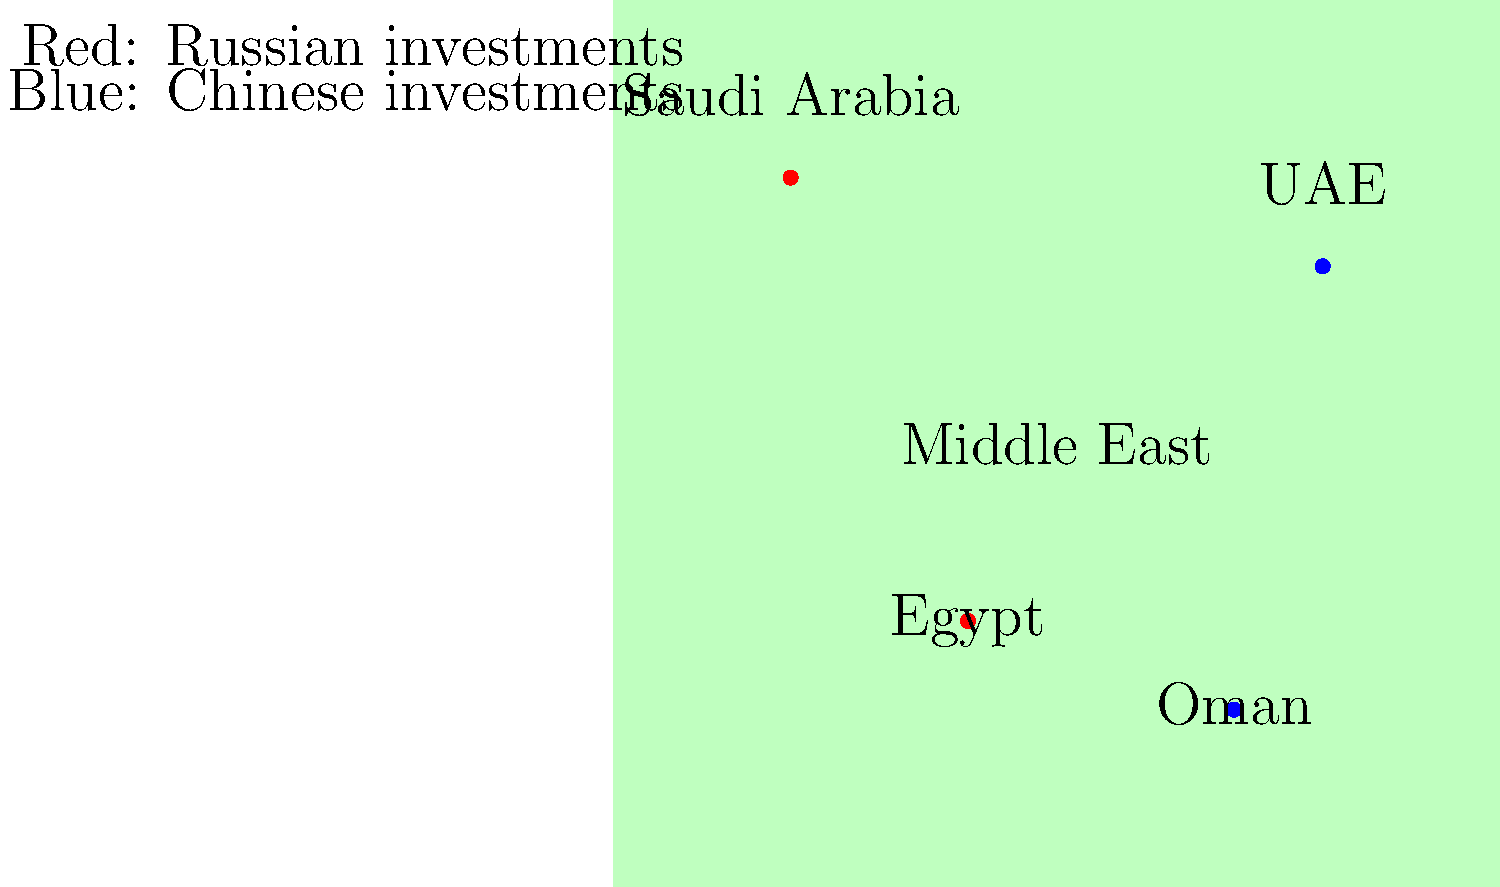Based on the color-coded map of Russian and Chinese economic investments in the Middle East, which country appears to have significant Chinese investment but is geographically closer to countries with Russian investment? To answer this question, we need to analyze the map step-by-step:

1. Identify the color coding:
   - Red dots represent Russian investments
   - Blue dots represent Chinese investments

2. Locate the countries with Russian investments:
   - Saudi Arabia (northern part of the map)
   - Egypt (southern part of the map)

3. Locate the countries with Chinese investments:
   - UAE (northern part of the map)
   - Oman (southern part of the map)

4. Analyze the geographical positions:
   - UAE (blue dot) is located in the northern part of the map
   - It is closer to Saudi Arabia (red dot) than to Oman (blue dot)

5. Consider the geopolitical implications:
   - UAE has Chinese investment but is geographically surrounded by areas of Russian influence
   - This positioning could potentially create interesting dynamics in terms of economic and political relations in the region

Therefore, the UAE stands out as a country with significant Chinese investment that is geographically closer to countries with Russian investment.
Answer: United Arab Emirates (UAE) 